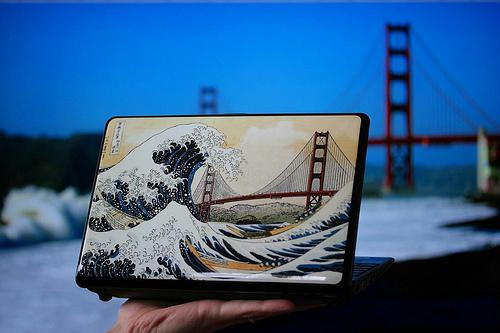Question: what picture is on the laptop?
Choices:
A. A sword.
B. A castle.
C. Waves.
D. A dog.
Answer with the letter. Answer: C Question: what are the waves covering?
Choices:
A. The street.
B. The grass.
C. The sand.
D. Bridge.
Answer with the letter. Answer: D Question: where is the picture?
Choices:
A. On a mountain.
B. In a park.
C. On a street.
D. Laptop.
Answer with the letter. Answer: D 